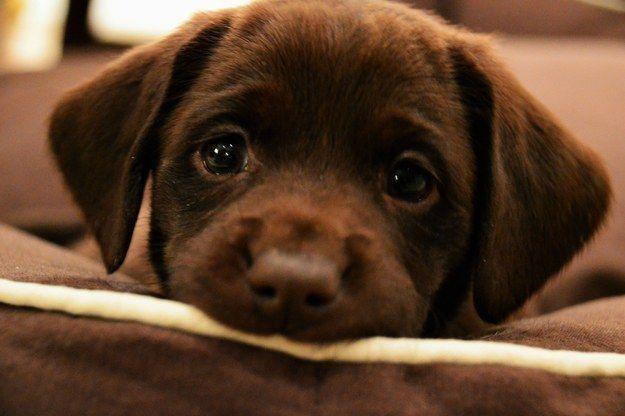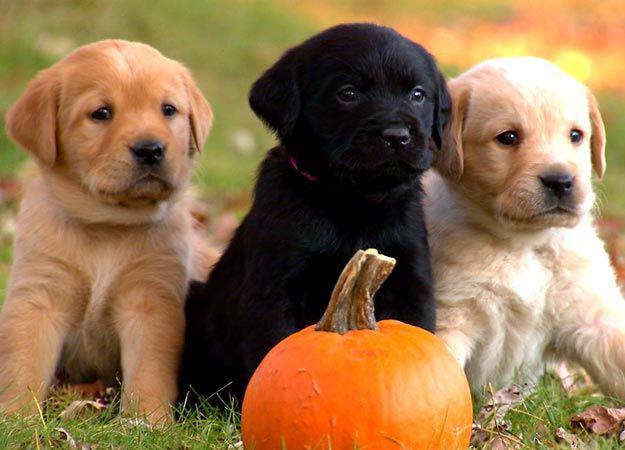The first image is the image on the left, the second image is the image on the right. Analyze the images presented: Is the assertion "An image shows a row of three dogs, with a black one in the middle." valid? Answer yes or no. Yes. The first image is the image on the left, the second image is the image on the right. Evaluate the accuracy of this statement regarding the images: "There are four dogs.". Is it true? Answer yes or no. Yes. 